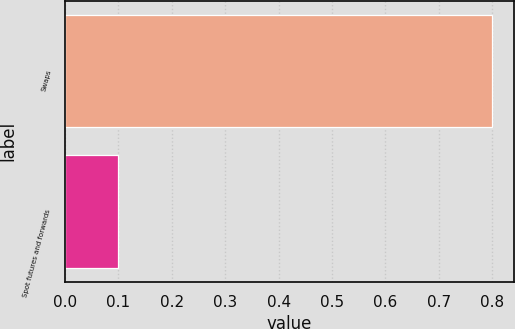<chart> <loc_0><loc_0><loc_500><loc_500><bar_chart><fcel>Swaps<fcel>Spot futures and forwards<nl><fcel>0.8<fcel>0.1<nl></chart> 